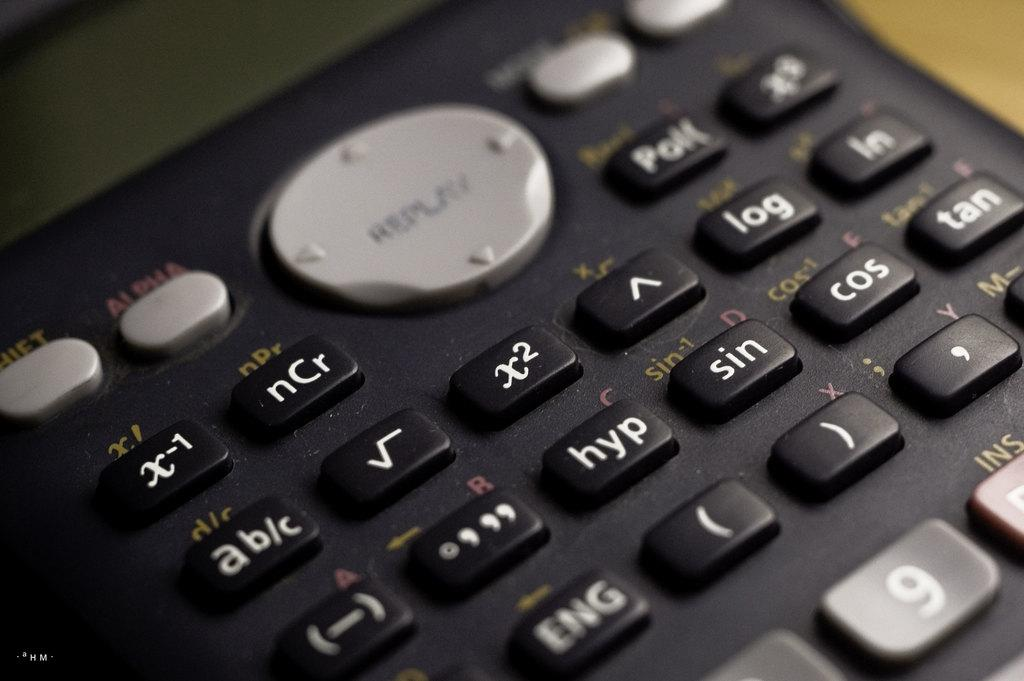<image>
Relay a brief, clear account of the picture shown. A close up of a calculator with various buttons such as sine and cosine. 